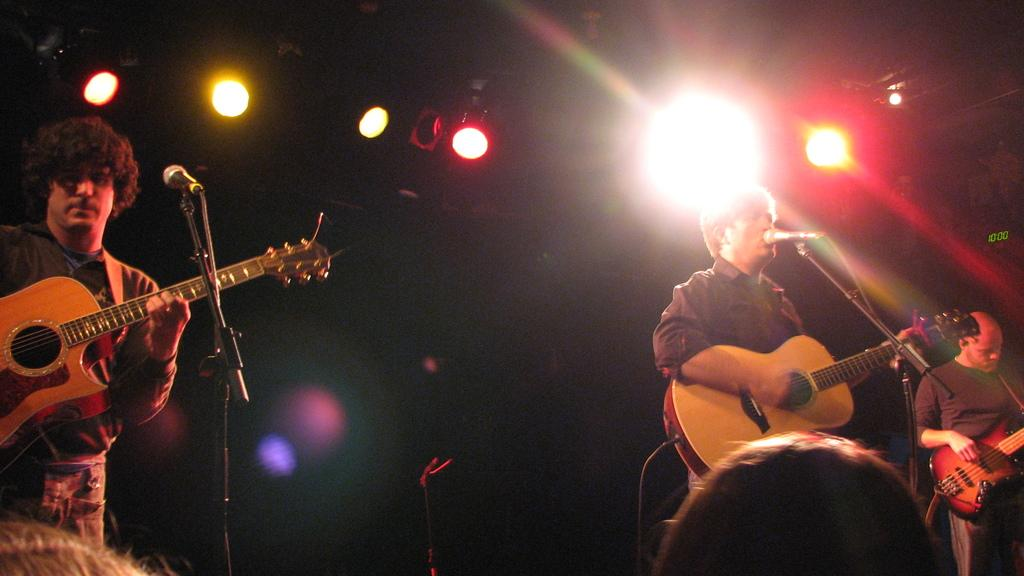How many people are in the image? There are three persons in the image. What are the persons wearing? The persons are wearing clothes. What activity are the persons engaged in? The persons are playing a guitar. What can be seen behind the two persons standing in front of the mic? There are lights at the top of the image. How many shelves can be seen in the image? There are no shelves present in the image. What is the amount of toothpaste used by the persons in the image? There is no toothpaste visible in the image, and the persons are not using any toothpaste. 